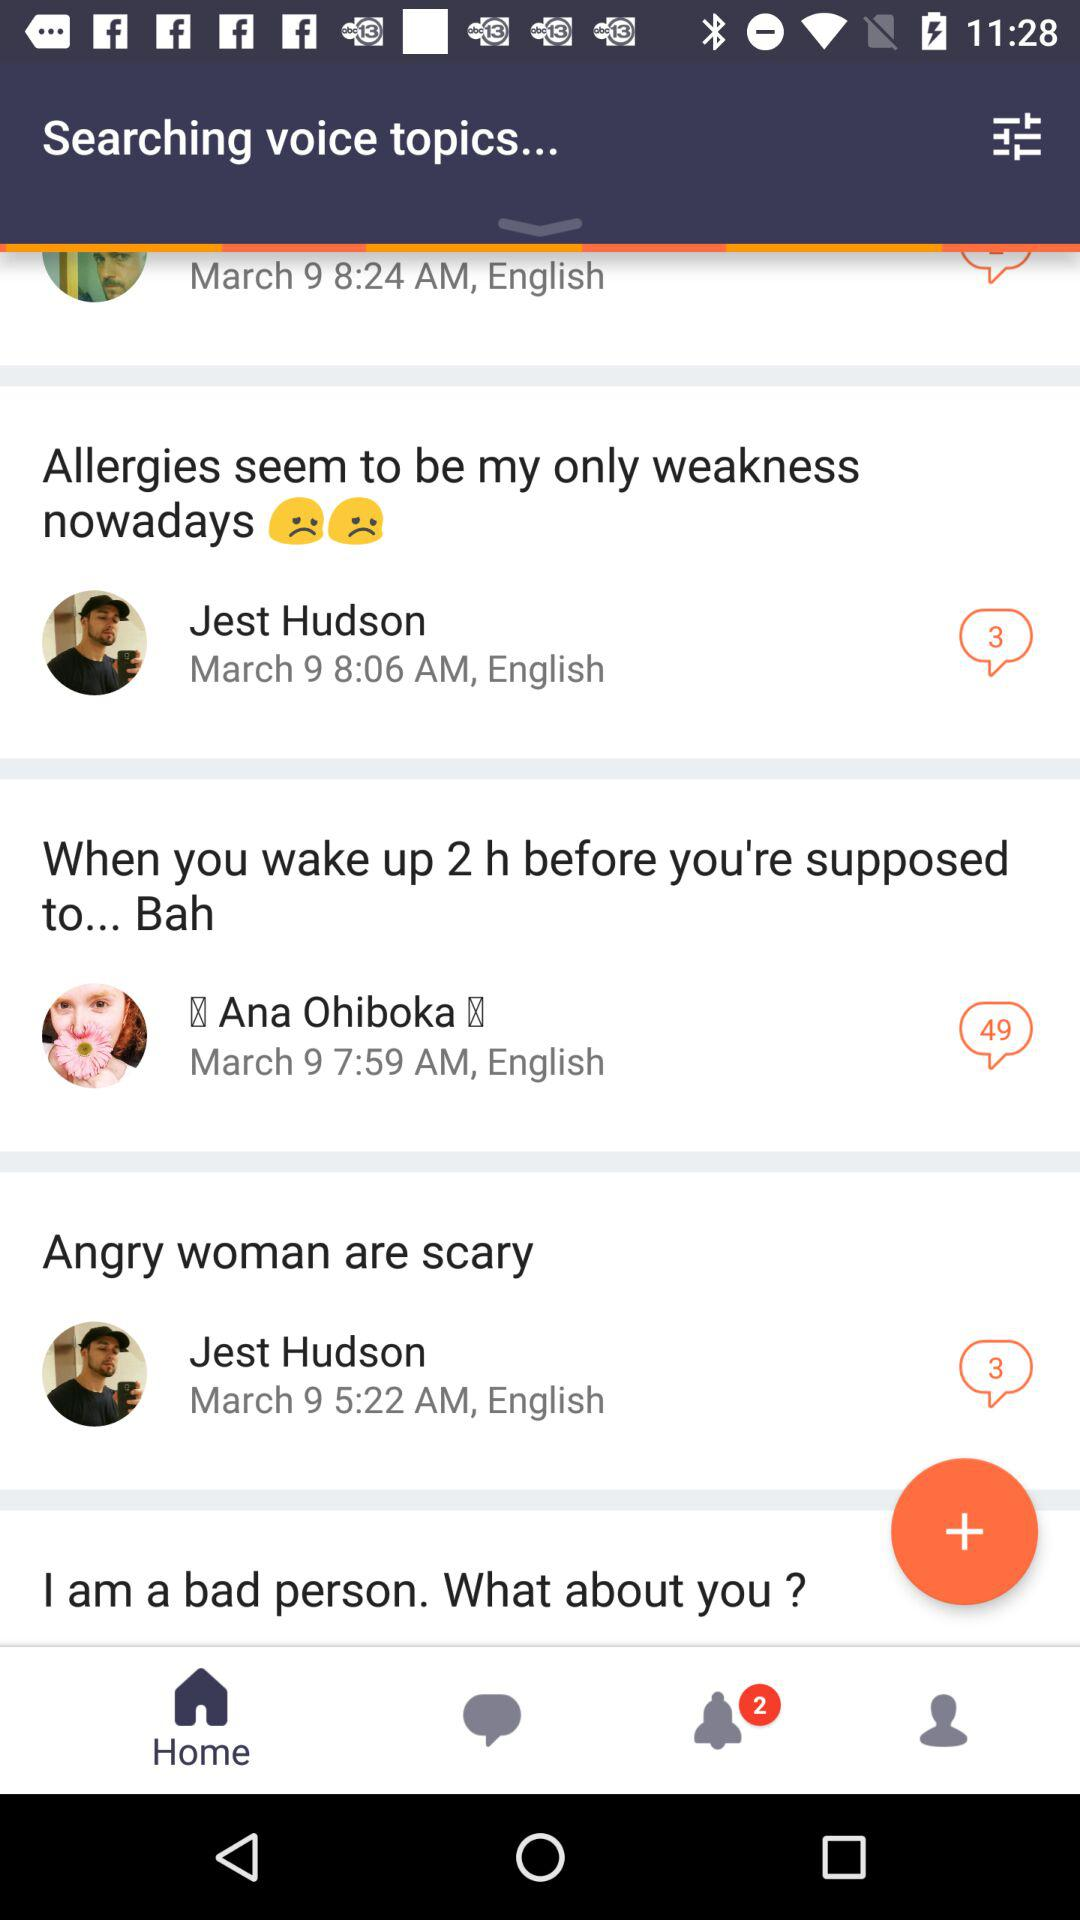What is the number of new notifications? The number of new notifications is 2. 